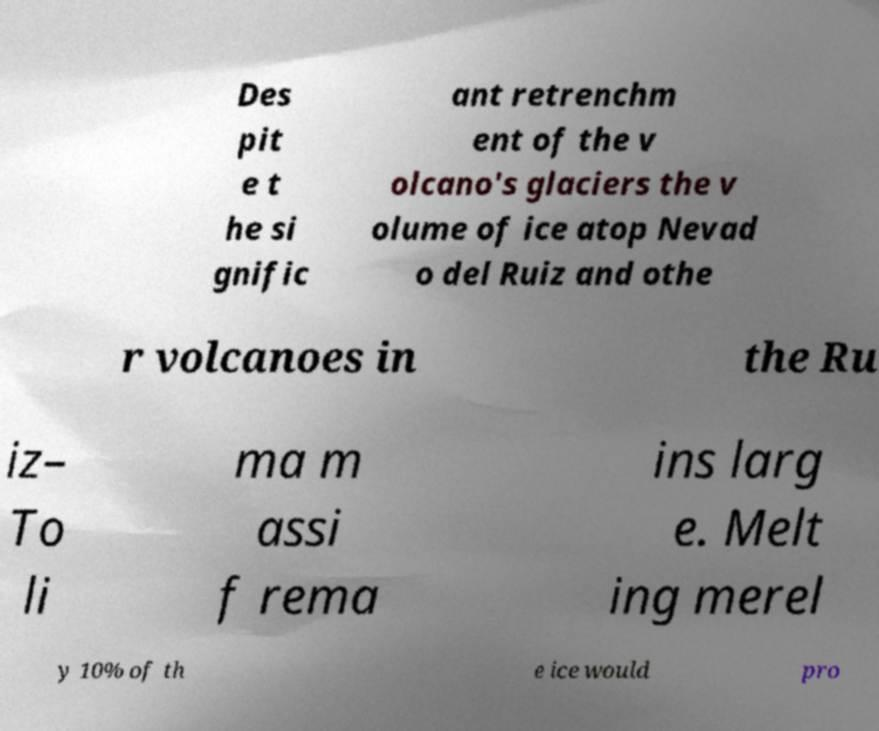What messages or text are displayed in this image? I need them in a readable, typed format. Des pit e t he si gnific ant retrenchm ent of the v olcano's glaciers the v olume of ice atop Nevad o del Ruiz and othe r volcanoes in the Ru iz– To li ma m assi f rema ins larg e. Melt ing merel y 10% of th e ice would pro 